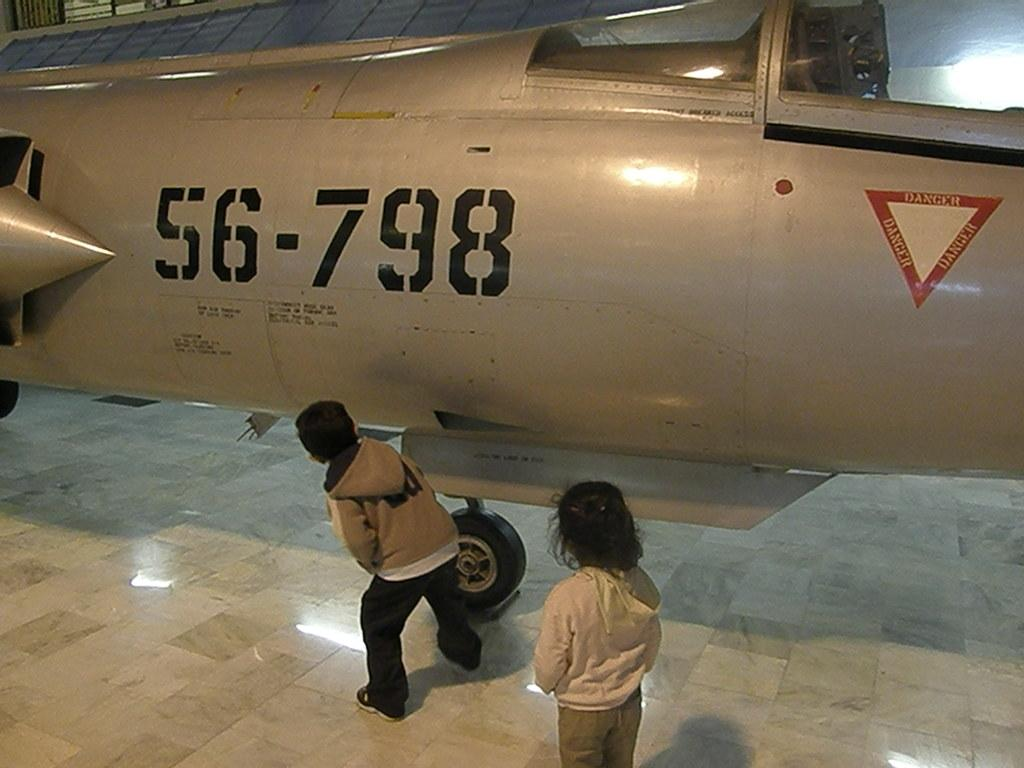<image>
Provide a brief description of the given image. Two kids looking at a jet with the number 56-798 on it 